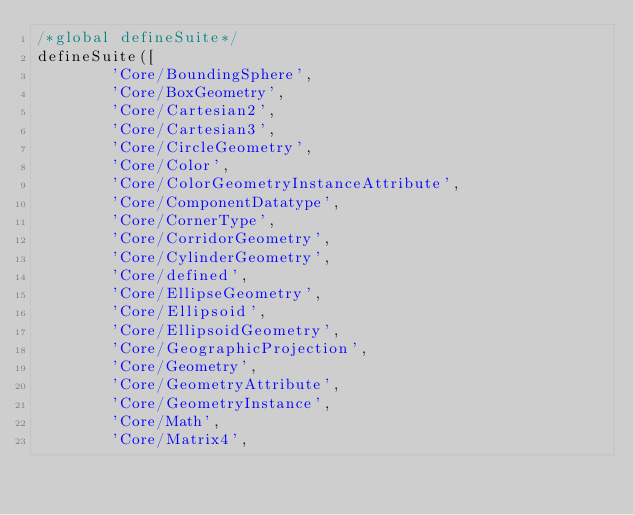Convert code to text. <code><loc_0><loc_0><loc_500><loc_500><_JavaScript_>/*global defineSuite*/
defineSuite([
        'Core/BoundingSphere',
        'Core/BoxGeometry',
        'Core/Cartesian2',
        'Core/Cartesian3',
        'Core/CircleGeometry',
        'Core/Color',
        'Core/ColorGeometryInstanceAttribute',
        'Core/ComponentDatatype',
        'Core/CornerType',
        'Core/CorridorGeometry',
        'Core/CylinderGeometry',
        'Core/defined',
        'Core/EllipseGeometry',
        'Core/Ellipsoid',
        'Core/EllipsoidGeometry',
        'Core/GeographicProjection',
        'Core/Geometry',
        'Core/GeometryAttribute',
        'Core/GeometryInstance',
        'Core/Math',
        'Core/Matrix4',</code> 